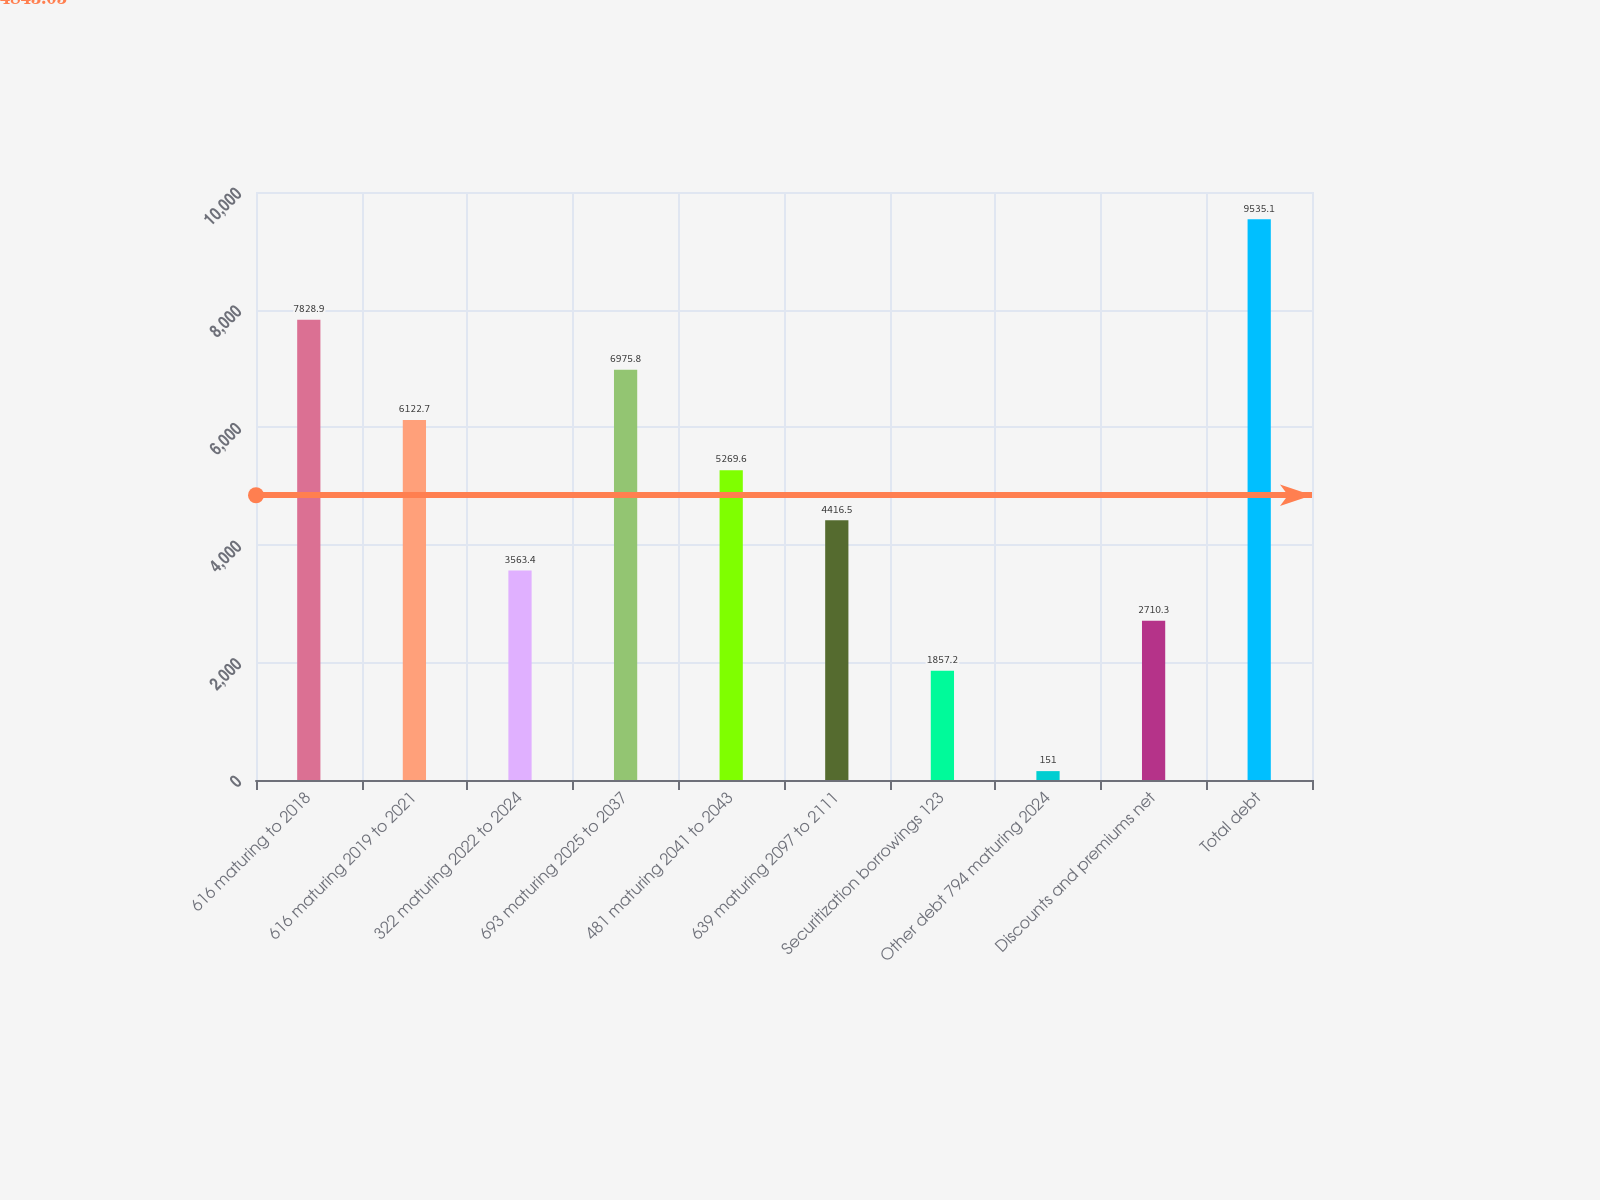Convert chart. <chart><loc_0><loc_0><loc_500><loc_500><bar_chart><fcel>616 maturing to 2018<fcel>616 maturing 2019 to 2021<fcel>322 maturing 2022 to 2024<fcel>693 maturing 2025 to 2037<fcel>481 maturing 2041 to 2043<fcel>639 maturing 2097 to 2111<fcel>Securitization borrowings 123<fcel>Other debt 794 maturing 2024<fcel>Discounts and premiums net<fcel>Total debt<nl><fcel>7828.9<fcel>6122.7<fcel>3563.4<fcel>6975.8<fcel>5269.6<fcel>4416.5<fcel>1857.2<fcel>151<fcel>2710.3<fcel>9535.1<nl></chart> 